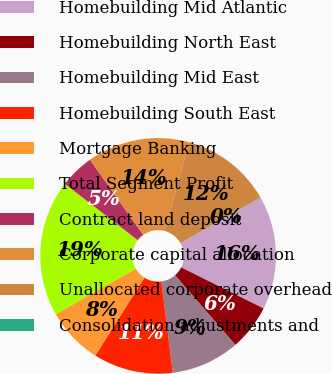Convert chart to OTSL. <chart><loc_0><loc_0><loc_500><loc_500><pie_chart><fcel>Homebuilding Mid Atlantic<fcel>Homebuilding North East<fcel>Homebuilding Mid East<fcel>Homebuilding South East<fcel>Mortgage Banking<fcel>Total Segment Profit<fcel>Contract land deposit<fcel>Corporate capital allocation<fcel>Unallocated corporate overhead<fcel>Consolidation adjustments and<nl><fcel>15.59%<fcel>6.27%<fcel>9.38%<fcel>10.93%<fcel>7.82%<fcel>18.7%<fcel>4.72%<fcel>14.04%<fcel>12.49%<fcel>0.05%<nl></chart> 